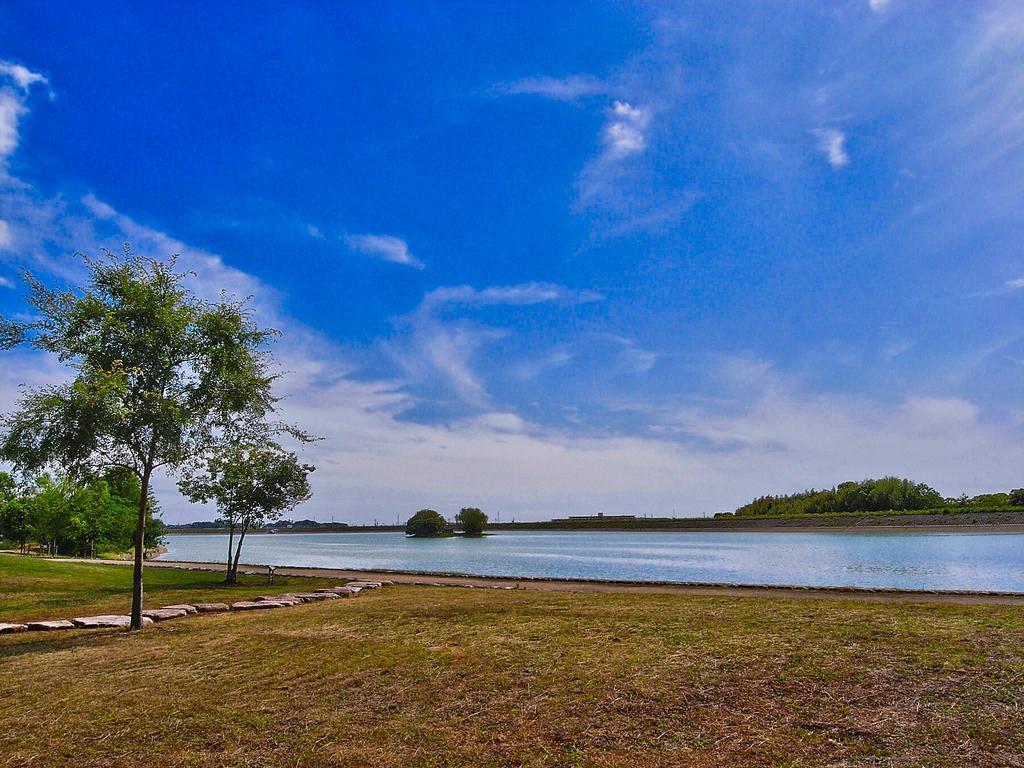Describe this image in one or two sentences. At the bottom of the picture, we see the grass. On the left side, we see the trees and stones. In the middle, we see the trees and water. This water might be in the canal. There are trees and poles in the background. At the top, we see the sky and the clouds. 